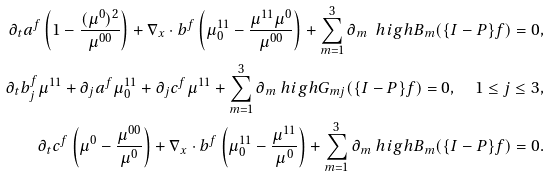<formula> <loc_0><loc_0><loc_500><loc_500>\partial _ { t } a ^ { f } \left ( 1 - \frac { ( \mu ^ { 0 } ) ^ { 2 } } { \mu ^ { 0 0 } } \right ) + \nabla _ { x } \cdot b ^ { f } \left ( \mu ^ { 1 1 } _ { 0 } - \frac { \mu ^ { 1 1 } \mu ^ { 0 } } { \mu ^ { 0 0 } } \right ) + \sum _ { m = 1 } ^ { 3 } \partial _ { m } \ h i g h B _ { m } ( \{ { I - P } \} f ) = 0 , \\ \partial _ { t } b _ { j } ^ { f } \mu ^ { 1 1 } + \partial _ { j } a ^ { f } \mu ^ { 1 1 } _ { 0 } + \partial _ { j } c ^ { f } \mu ^ { 1 1 } + \sum _ { m = 1 } ^ { 3 } \partial _ { m } \ h i g h G _ { m j } ( \{ { I - P } \} f ) = 0 , \quad 1 \leq j \leq 3 , \\ \partial _ { t } c ^ { f } \left ( \mu ^ { 0 } - \frac { \mu ^ { 0 0 } } { \mu ^ { 0 } } \right ) + \nabla _ { x } \cdot b ^ { f } \left ( \mu ^ { 1 1 } _ { 0 } - \frac { \mu ^ { 1 1 } } { \mu ^ { 0 } } \right ) + \sum _ { m = 1 } ^ { 3 } \partial _ { m } \ h i g h B _ { m } ( \{ { I - P } \} f ) = 0 .</formula> 